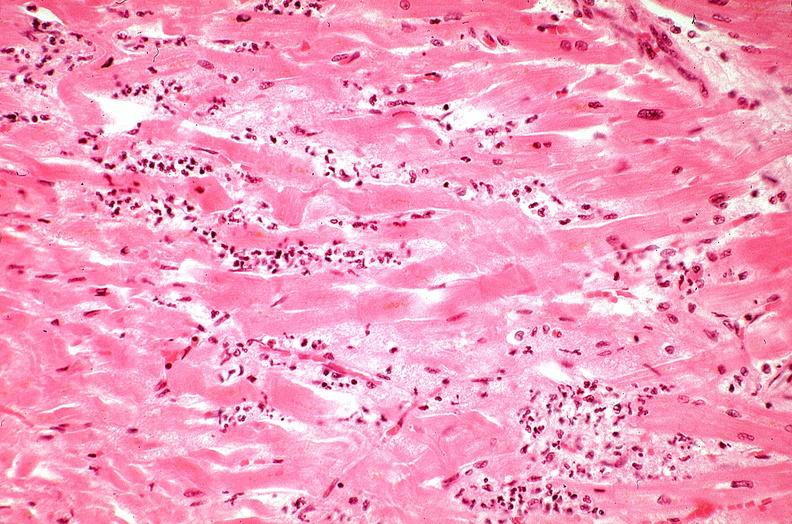what is present?
Answer the question using a single word or phrase. Cardiovascular 